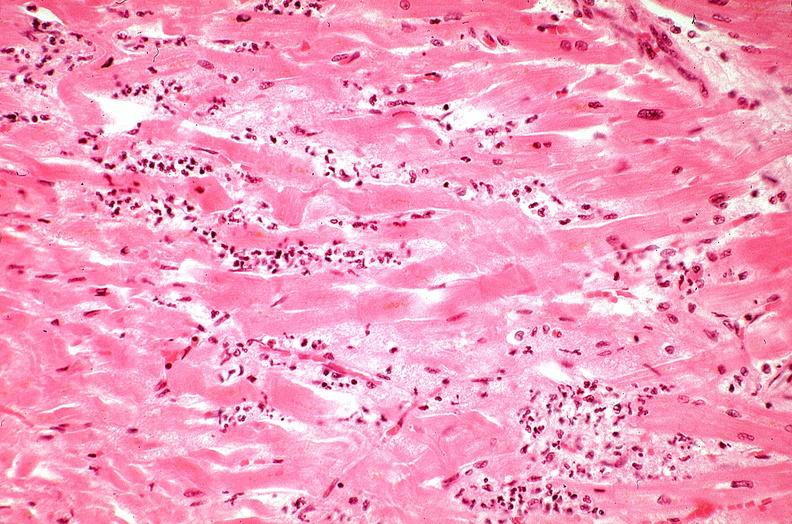what is present?
Answer the question using a single word or phrase. Cardiovascular 